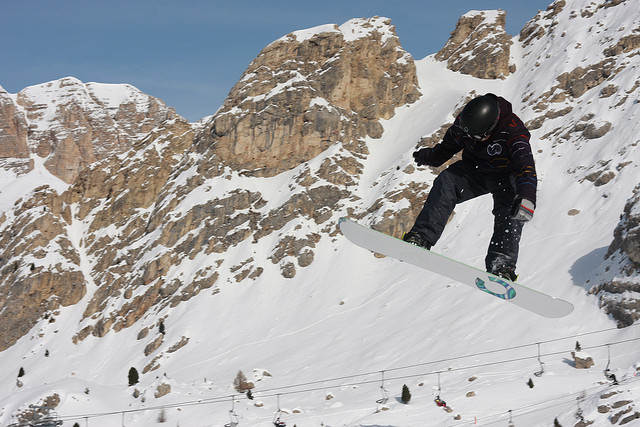How many people can you see in the image? There is one person visible in the image, focusing the viewer's attention on the dynamic action of their snowboarding jump. 